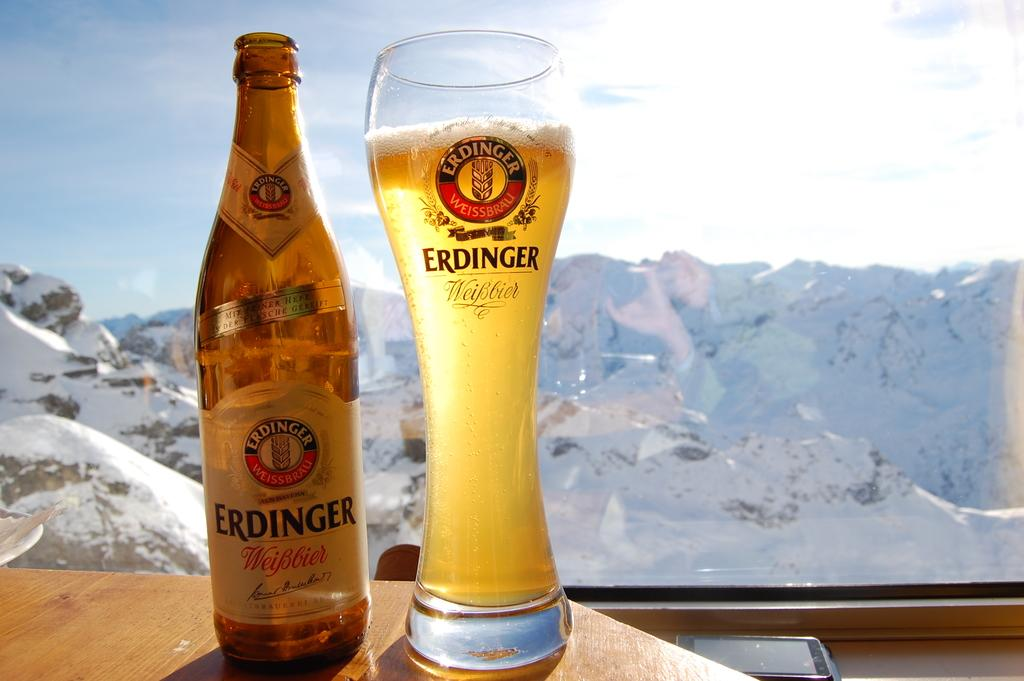<image>
Render a clear and concise summary of the photo. A bottle of Erdinger beer is next to a full glass with a snowy mountain in the background. 